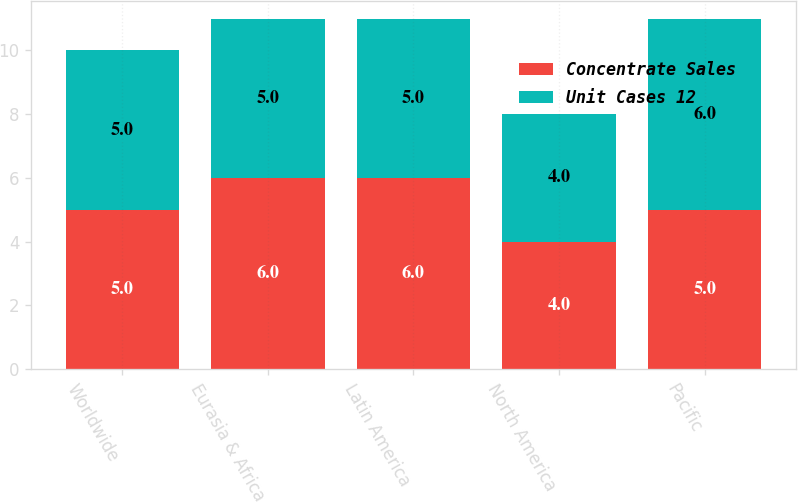Convert chart to OTSL. <chart><loc_0><loc_0><loc_500><loc_500><stacked_bar_chart><ecel><fcel>Worldwide<fcel>Eurasia & Africa<fcel>Latin America<fcel>North America<fcel>Pacific<nl><fcel>Concentrate Sales<fcel>5<fcel>6<fcel>6<fcel>4<fcel>5<nl><fcel>Unit Cases 12<fcel>5<fcel>5<fcel>5<fcel>4<fcel>6<nl></chart> 